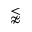Convert formula to latex. <formula><loc_0><loc_0><loc_500><loc_500>\lnapprox</formula> 